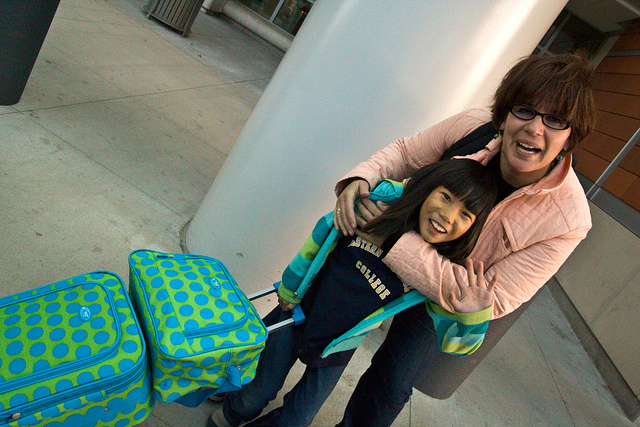Why is the young girl holding luggage?
A. to purchase
B. to sell
C. to travel
D. to pack
Answer with the option's letter from the given choices directly. C 